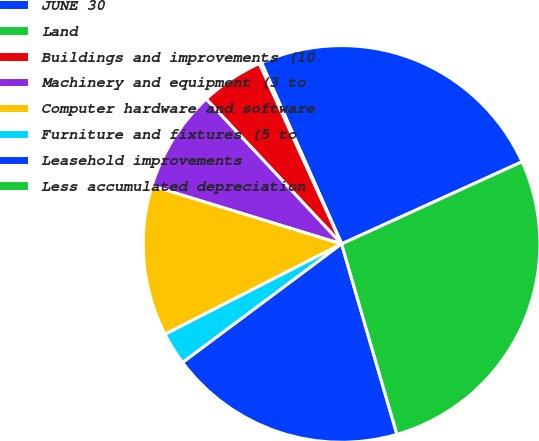Convert chart to OTSL. <chart><loc_0><loc_0><loc_500><loc_500><pie_chart><fcel>JUNE 30<fcel>Land<fcel>Buildings and improvements (10<fcel>Machinery and equipment (3 to<fcel>Computer hardware and software<fcel>Furniture and fixtures (5 to<fcel>Leasehold improvements<fcel>Less accumulated depreciation<nl><fcel>24.82%<fcel>0.19%<fcel>5.15%<fcel>8.31%<fcel>12.26%<fcel>2.67%<fcel>19.3%<fcel>27.3%<nl></chart> 